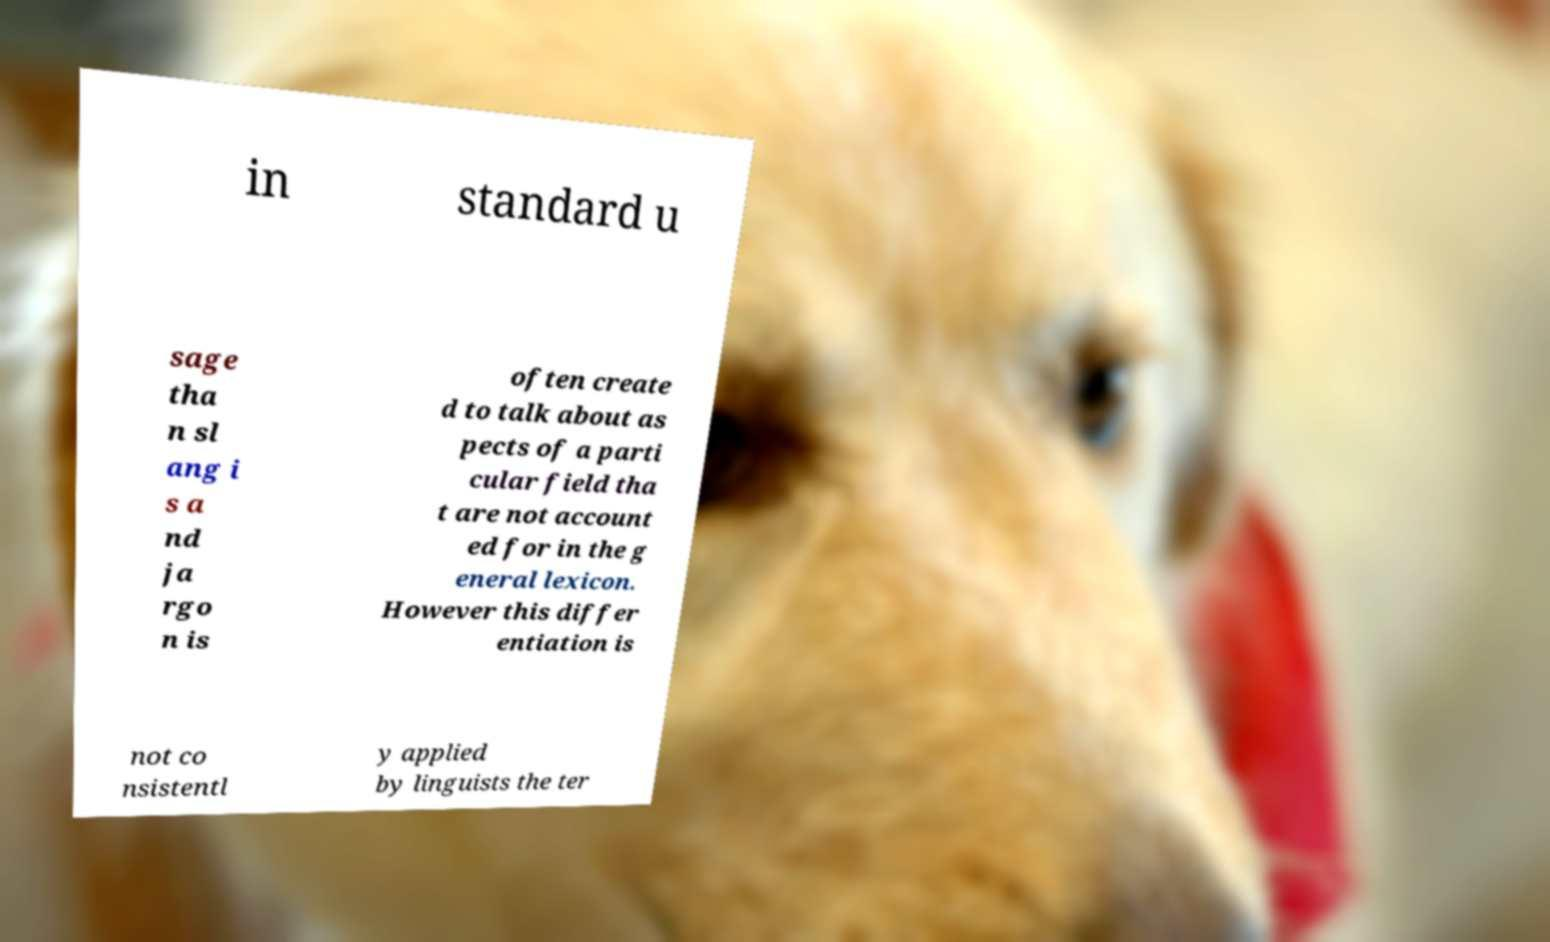Please identify and transcribe the text found in this image. in standard u sage tha n sl ang i s a nd ja rgo n is often create d to talk about as pects of a parti cular field tha t are not account ed for in the g eneral lexicon. However this differ entiation is not co nsistentl y applied by linguists the ter 